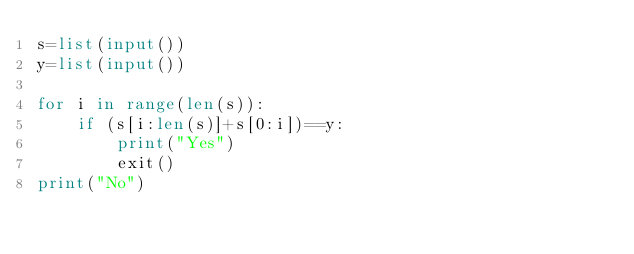<code> <loc_0><loc_0><loc_500><loc_500><_Python_>s=list(input())
y=list(input())

for i in range(len(s)):
    if (s[i:len(s)]+s[0:i])==y:
        print("Yes")
        exit()
print("No")</code> 